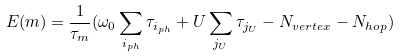Convert formula to latex. <formula><loc_0><loc_0><loc_500><loc_500>E ( m ) = \frac { 1 } { \tau _ { m } } ( \omega _ { 0 } \sum _ { i _ { p h } } \tau _ { i _ { p h } } + U \sum _ { j _ { U } } \tau _ { j _ { U } } - N _ { v e r t e x } - N _ { h o p } )</formula> 